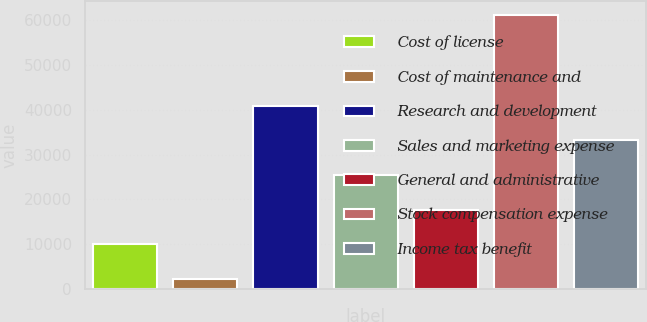<chart> <loc_0><loc_0><loc_500><loc_500><bar_chart><fcel>Cost of license<fcel>Cost of maintenance and<fcel>Research and development<fcel>Sales and marketing expense<fcel>General and administrative<fcel>Stock compensation expense<fcel>Income tax benefit<nl><fcel>10046.4<fcel>2336<fcel>40888<fcel>25467.2<fcel>17756.8<fcel>61216<fcel>33177.6<nl></chart> 